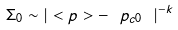<formula> <loc_0><loc_0><loc_500><loc_500>\Sigma _ { 0 } \sim | < p > - \ p _ { c 0 } \ | ^ { - k }</formula> 